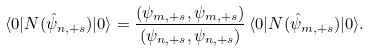Convert formula to latex. <formula><loc_0><loc_0><loc_500><loc_500>\langle 0 | N ( \hat { \psi } _ { n , + s } ) | 0 \rangle = \frac { ( \psi _ { m , + s } , \psi _ { m , + s } ) } { ( \psi _ { n , + s } , \psi _ { n , + s } ) } \, \langle 0 | N ( \hat { \psi } _ { m , + s } ) | 0 \rangle .</formula> 